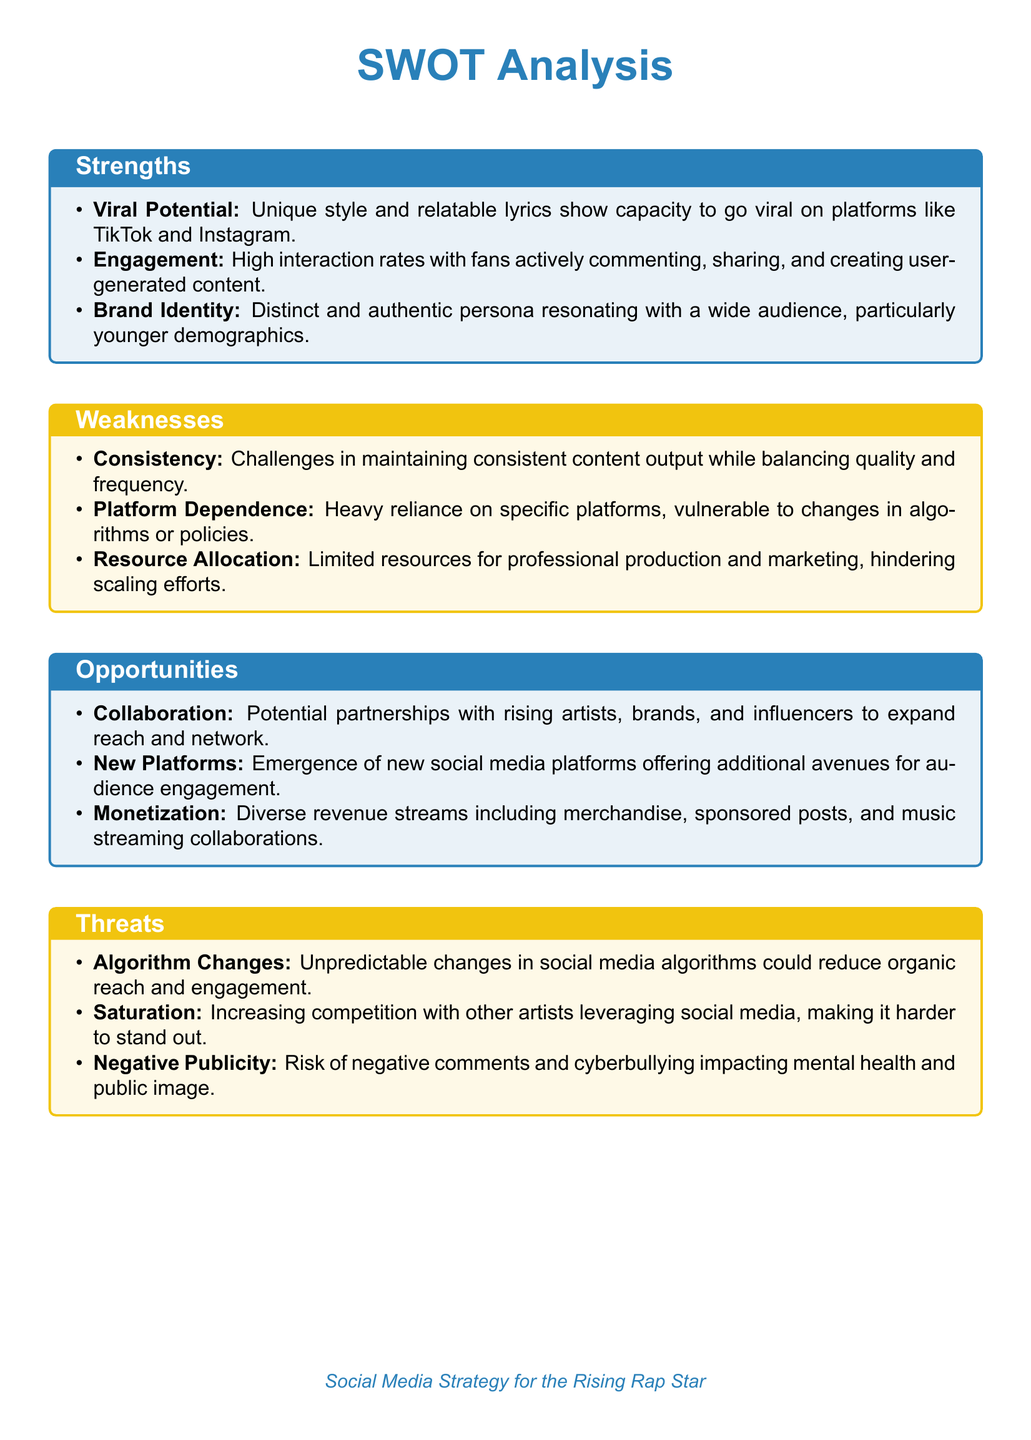What are the strengths listed? The strengths mentioned are Viral Potential, Engagement, and Brand Identity.
Answer: Viral Potential, Engagement, Brand Identity What is one weakness referencing content output? The document states that consistency is a challenge in maintaining content output.
Answer: Consistency What opportunities are included for expanding reach? The document mentions potential collaborations with rising artists and brands as an opportunity.
Answer: Collaboration Which color represents weaknesses in the document? The weaknesses section is represented by the color gold.
Answer: Gold What is a threat posed by social media algorithm? Unpredictable changes in algorithms could reduce organic reach and engagement.
Answer: Algorithm Changes How many strengths are identified in the SWOT analysis? There are three strengths listed in the strengths section.
Answer: Three What is a new avenue for audience engagement mentioned? The emergence of new social media platforms offers additional avenues for audience engagement.
Answer: New Platforms What type of strategy is discussed for the rising rap star? The document focuses on Social Media Strategy.
Answer: Social Media Strategy What risk is associated with negative comments? The document states that negative publicity can impact mental health and public image.
Answer: Negative Publicity 